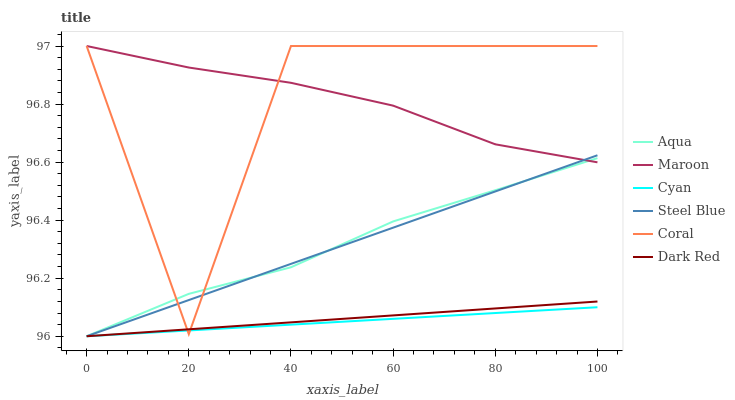Does Cyan have the minimum area under the curve?
Answer yes or no. Yes. Does Maroon have the maximum area under the curve?
Answer yes or no. Yes. Does Coral have the minimum area under the curve?
Answer yes or no. No. Does Coral have the maximum area under the curve?
Answer yes or no. No. Is Steel Blue the smoothest?
Answer yes or no. Yes. Is Coral the roughest?
Answer yes or no. Yes. Is Aqua the smoothest?
Answer yes or no. No. Is Aqua the roughest?
Answer yes or no. No. Does Dark Red have the lowest value?
Answer yes or no. Yes. Does Coral have the lowest value?
Answer yes or no. No. Does Maroon have the highest value?
Answer yes or no. Yes. Does Aqua have the highest value?
Answer yes or no. No. Is Cyan less than Maroon?
Answer yes or no. Yes. Is Maroon greater than Cyan?
Answer yes or no. Yes. Does Steel Blue intersect Dark Red?
Answer yes or no. Yes. Is Steel Blue less than Dark Red?
Answer yes or no. No. Is Steel Blue greater than Dark Red?
Answer yes or no. No. Does Cyan intersect Maroon?
Answer yes or no. No. 